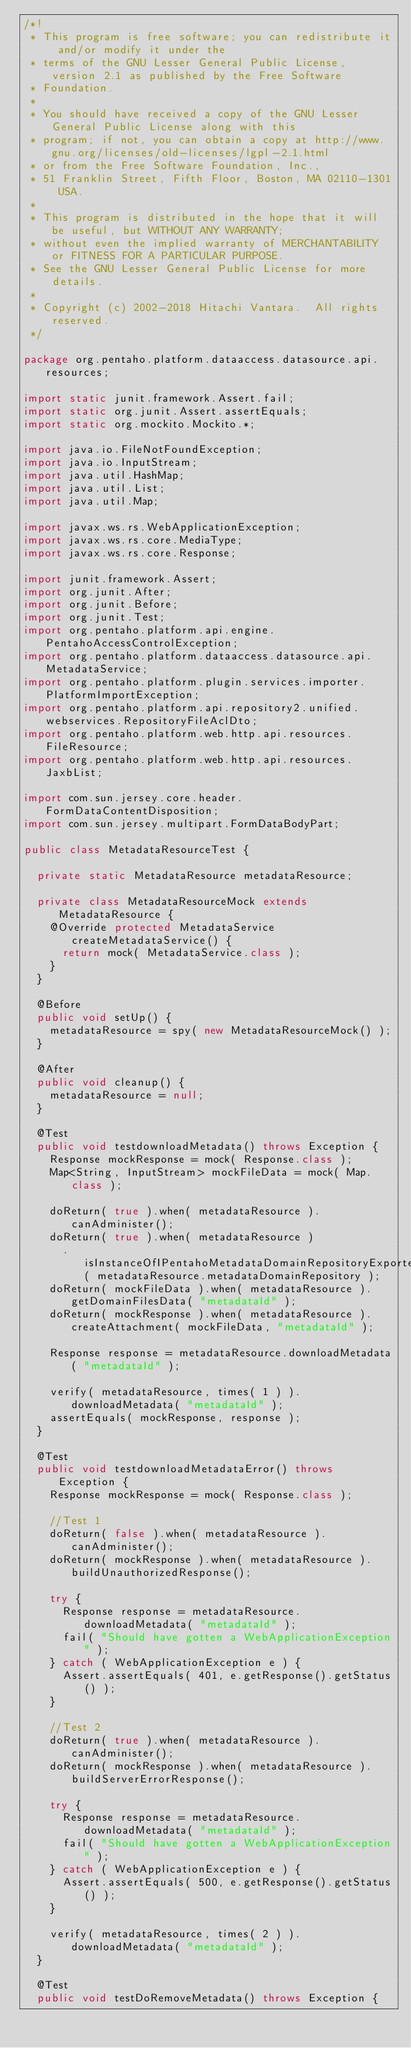Convert code to text. <code><loc_0><loc_0><loc_500><loc_500><_Java_>/*!
 * This program is free software; you can redistribute it and/or modify it under the
 * terms of the GNU Lesser General Public License, version 2.1 as published by the Free Software
 * Foundation.
 *
 * You should have received a copy of the GNU Lesser General Public License along with this
 * program; if not, you can obtain a copy at http://www.gnu.org/licenses/old-licenses/lgpl-2.1.html
 * or from the Free Software Foundation, Inc.,
 * 51 Franklin Street, Fifth Floor, Boston, MA 02110-1301 USA.
 *
 * This program is distributed in the hope that it will be useful, but WITHOUT ANY WARRANTY;
 * without even the implied warranty of MERCHANTABILITY or FITNESS FOR A PARTICULAR PURPOSE.
 * See the GNU Lesser General Public License for more details.
 *
 * Copyright (c) 2002-2018 Hitachi Vantara.  All rights reserved.
 */

package org.pentaho.platform.dataaccess.datasource.api.resources;

import static junit.framework.Assert.fail;
import static org.junit.Assert.assertEquals;
import static org.mockito.Mockito.*;

import java.io.FileNotFoundException;
import java.io.InputStream;
import java.util.HashMap;
import java.util.List;
import java.util.Map;

import javax.ws.rs.WebApplicationException;
import javax.ws.rs.core.MediaType;
import javax.ws.rs.core.Response;

import junit.framework.Assert;
import org.junit.After;
import org.junit.Before;
import org.junit.Test;
import org.pentaho.platform.api.engine.PentahoAccessControlException;
import org.pentaho.platform.dataaccess.datasource.api.MetadataService;
import org.pentaho.platform.plugin.services.importer.PlatformImportException;
import org.pentaho.platform.api.repository2.unified.webservices.RepositoryFileAclDto;
import org.pentaho.platform.web.http.api.resources.FileResource;
import org.pentaho.platform.web.http.api.resources.JaxbList;

import com.sun.jersey.core.header.FormDataContentDisposition;
import com.sun.jersey.multipart.FormDataBodyPart;

public class MetadataResourceTest {

  private static MetadataResource metadataResource;

  private class MetadataResourceMock extends MetadataResource {
    @Override protected MetadataService createMetadataService() {
      return mock( MetadataService.class );
    }
  }

  @Before
  public void setUp() {
    metadataResource = spy( new MetadataResourceMock() );
  }

  @After
  public void cleanup() {
    metadataResource = null;
  }

  @Test
  public void testdownloadMetadata() throws Exception {
    Response mockResponse = mock( Response.class );
    Map<String, InputStream> mockFileData = mock( Map.class );

    doReturn( true ).when( metadataResource ).canAdminister();
    doReturn( true ).when( metadataResource )
      .isInstanceOfIPentahoMetadataDomainRepositoryExporter( metadataResource.metadataDomainRepository );
    doReturn( mockFileData ).when( metadataResource ).getDomainFilesData( "metadataId" );
    doReturn( mockResponse ).when( metadataResource ).createAttachment( mockFileData, "metadataId" );

    Response response = metadataResource.downloadMetadata( "metadataId" );

    verify( metadataResource, times( 1 ) ).downloadMetadata( "metadataId" );
    assertEquals( mockResponse, response );
  }

  @Test
  public void testdownloadMetadataError() throws Exception {
    Response mockResponse = mock( Response.class );

    //Test 1
    doReturn( false ).when( metadataResource ).canAdminister();
    doReturn( mockResponse ).when( metadataResource ).buildUnauthorizedResponse();

    try {
      Response response = metadataResource.downloadMetadata( "metadataId" );
      fail( "Should have gotten a WebApplicationException" );
    } catch ( WebApplicationException e ) {
      Assert.assertEquals( 401, e.getResponse().getStatus() );
    }

    //Test 2
    doReturn( true ).when( metadataResource ).canAdminister();
    doReturn( mockResponse ).when( metadataResource ).buildServerErrorResponse();

    try {
      Response response = metadataResource.downloadMetadata( "metadataId" );
      fail( "Should have gotten a WebApplicationException" );
    } catch ( WebApplicationException e ) {
      Assert.assertEquals( 500, e.getResponse().getStatus() );
    }

    verify( metadataResource, times( 2 ) ).downloadMetadata( "metadataId" );
  }

  @Test
  public void testDoRemoveMetadata() throws Exception {</code> 